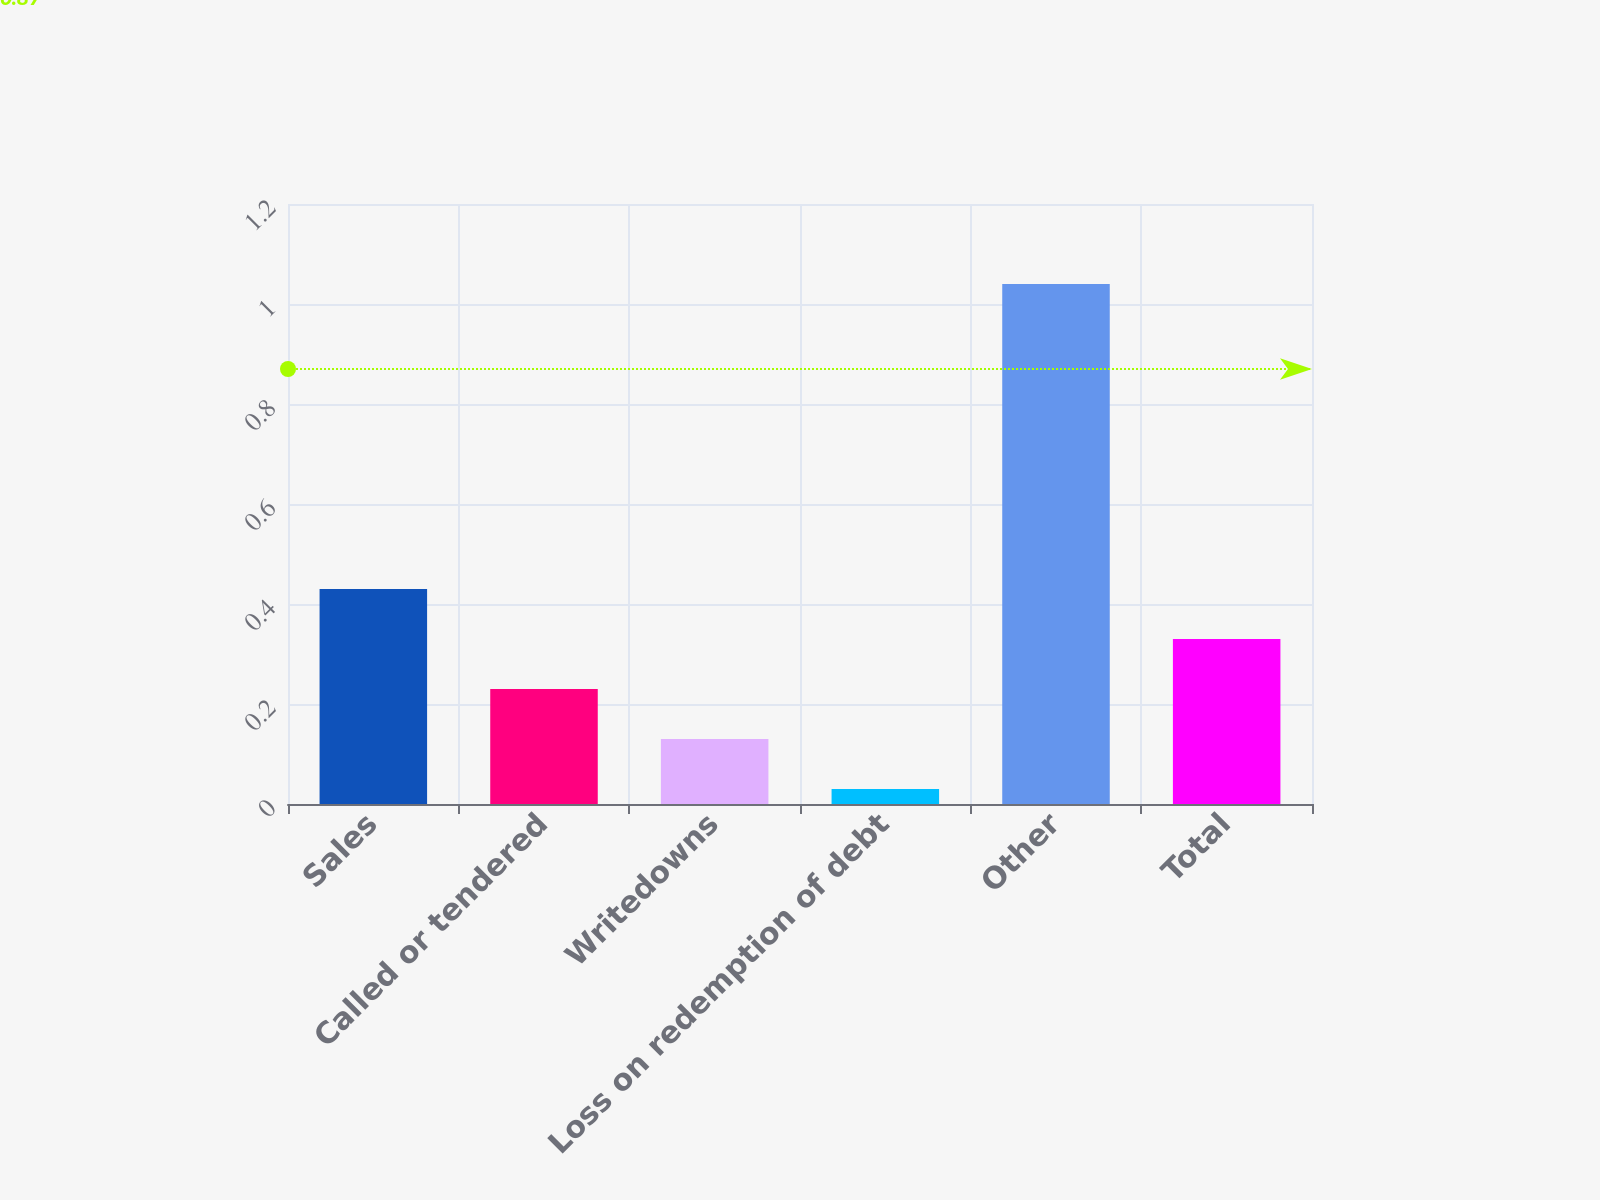<chart> <loc_0><loc_0><loc_500><loc_500><bar_chart><fcel>Sales<fcel>Called or tendered<fcel>Writedowns<fcel>Loss on redemption of debt<fcel>Other<fcel>Total<nl><fcel>0.43<fcel>0.23<fcel>0.13<fcel>0.03<fcel>1.04<fcel>0.33<nl></chart> 